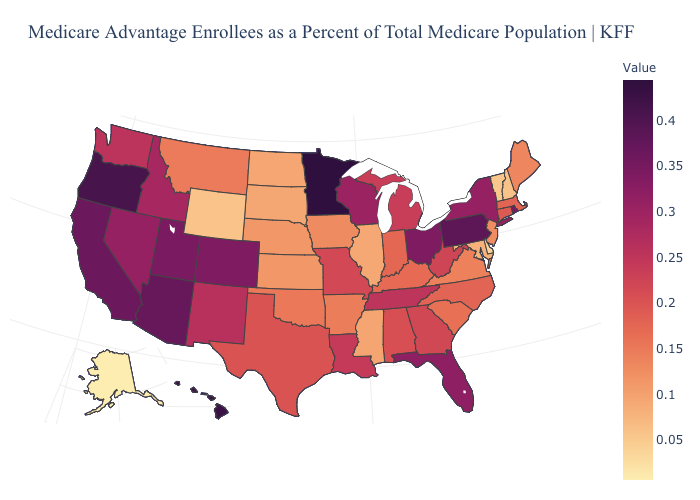Does Minnesota have the highest value in the USA?
Keep it brief. Yes. Which states have the lowest value in the USA?
Be succinct. Alaska. Does the map have missing data?
Give a very brief answer. No. Does Alabama have a higher value than Vermont?
Answer briefly. Yes. Which states have the highest value in the USA?
Be succinct. Minnesota. 